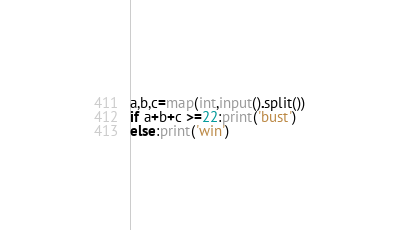<code> <loc_0><loc_0><loc_500><loc_500><_Python_>a,b,c=map(int,input().split())
if a+b+c >=22:print('bust')
else:print('win')</code> 